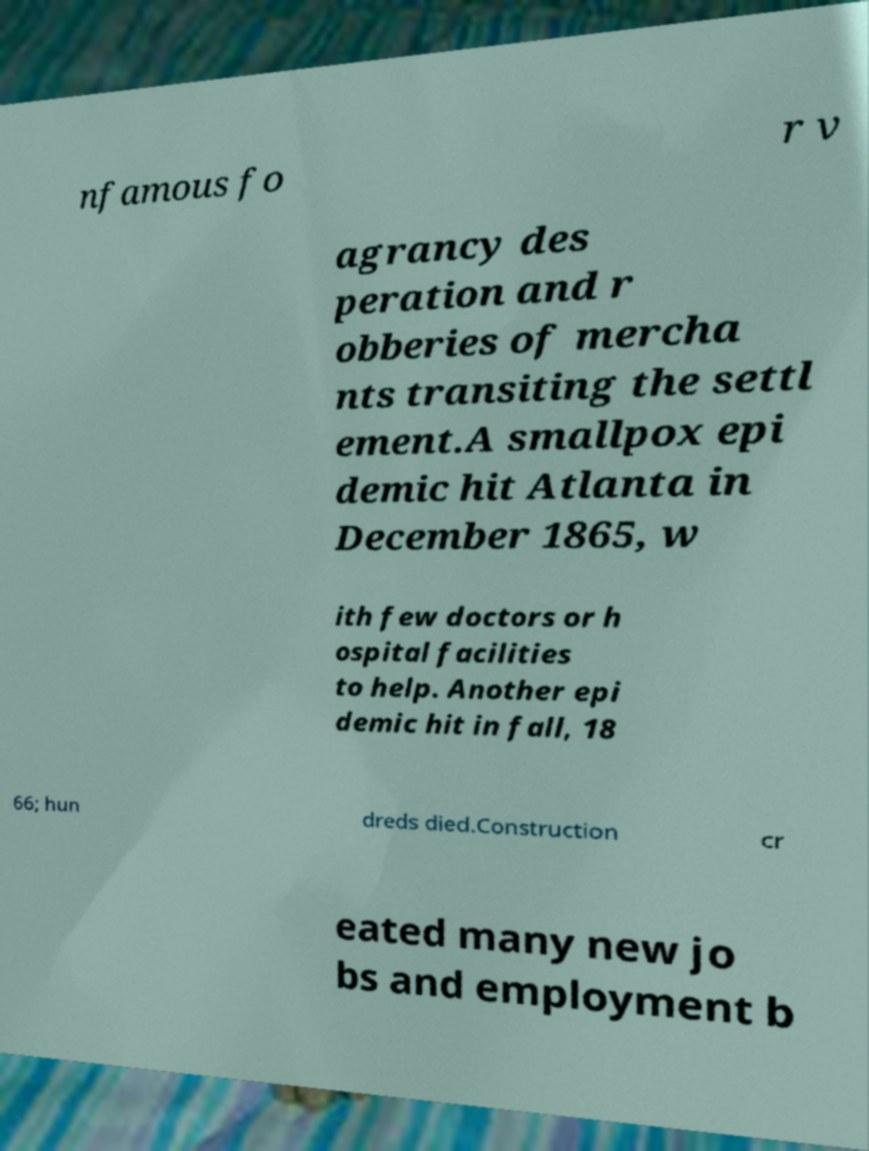Can you accurately transcribe the text from the provided image for me? nfamous fo r v agrancy des peration and r obberies of mercha nts transiting the settl ement.A smallpox epi demic hit Atlanta in December 1865, w ith few doctors or h ospital facilities to help. Another epi demic hit in fall, 18 66; hun dreds died.Construction cr eated many new jo bs and employment b 